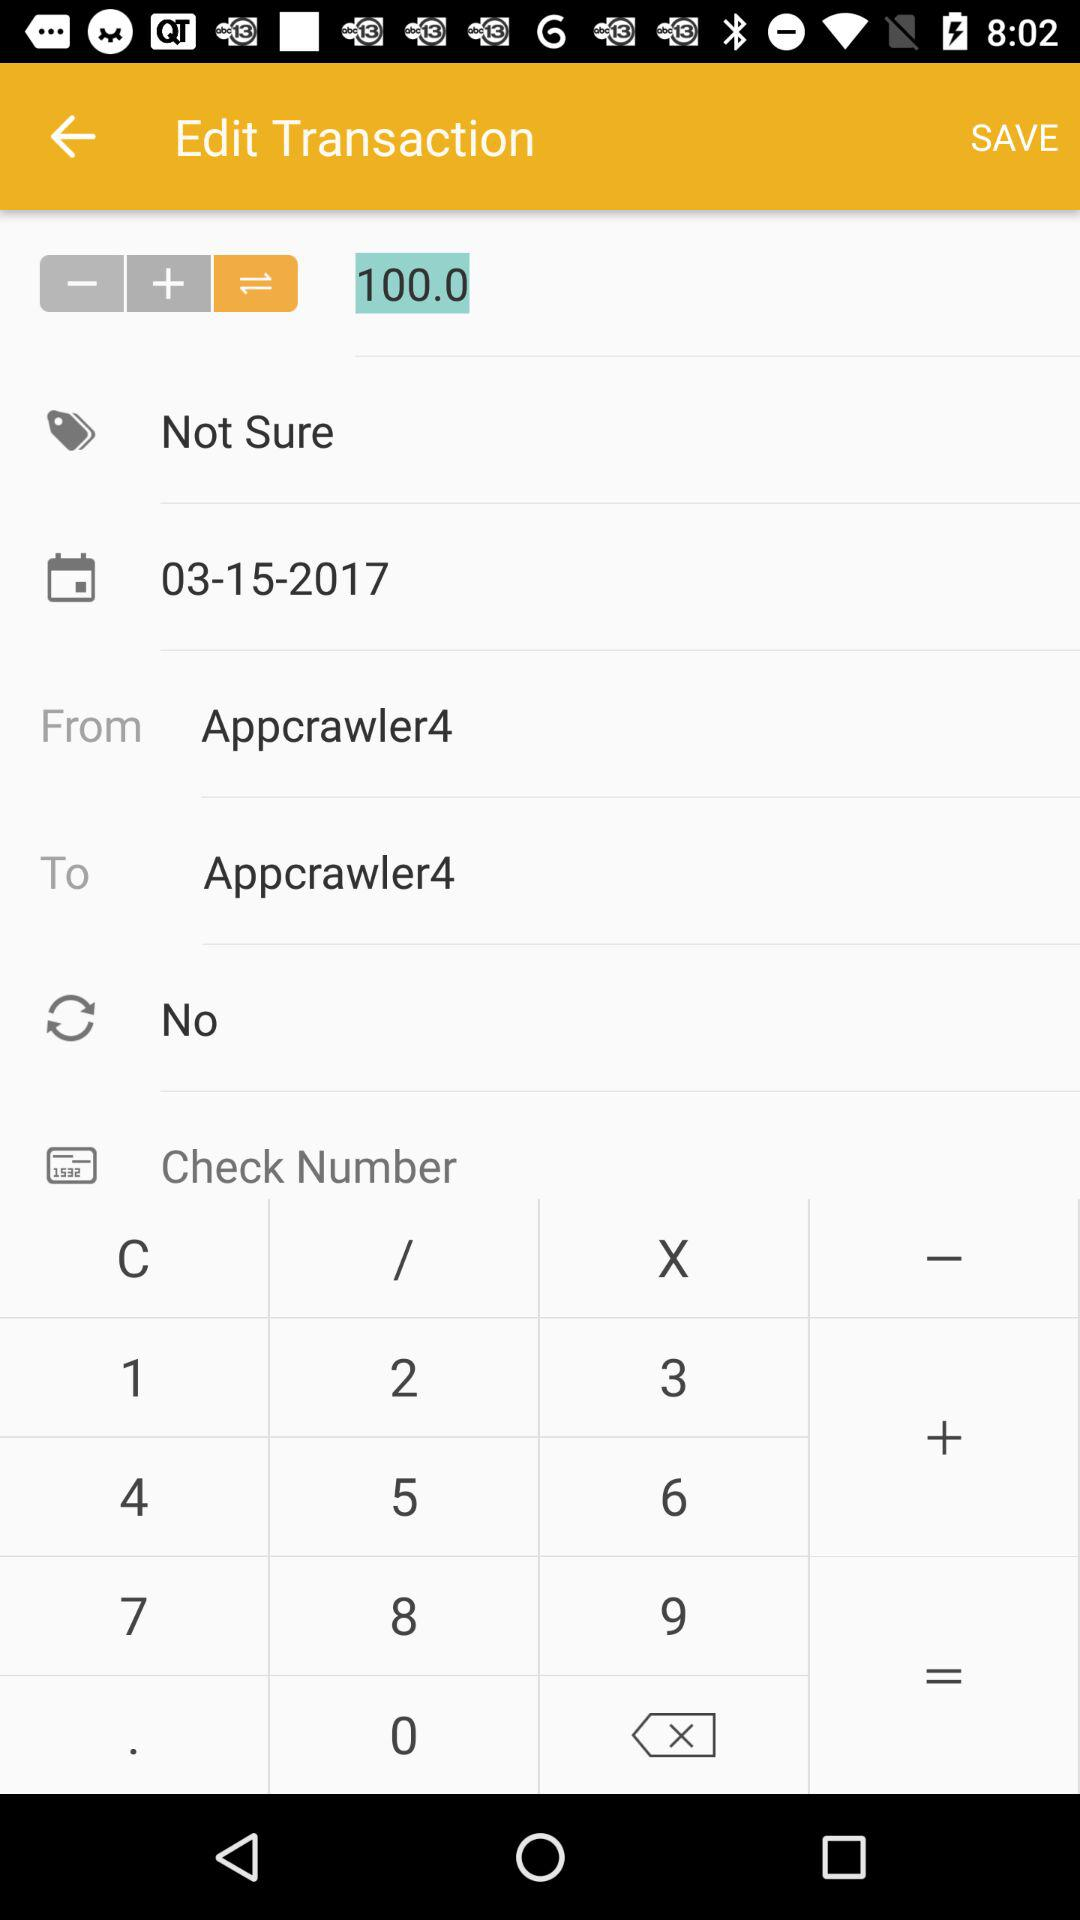How much is the transaction amount?
Answer the question using a single word or phrase. 100.0 